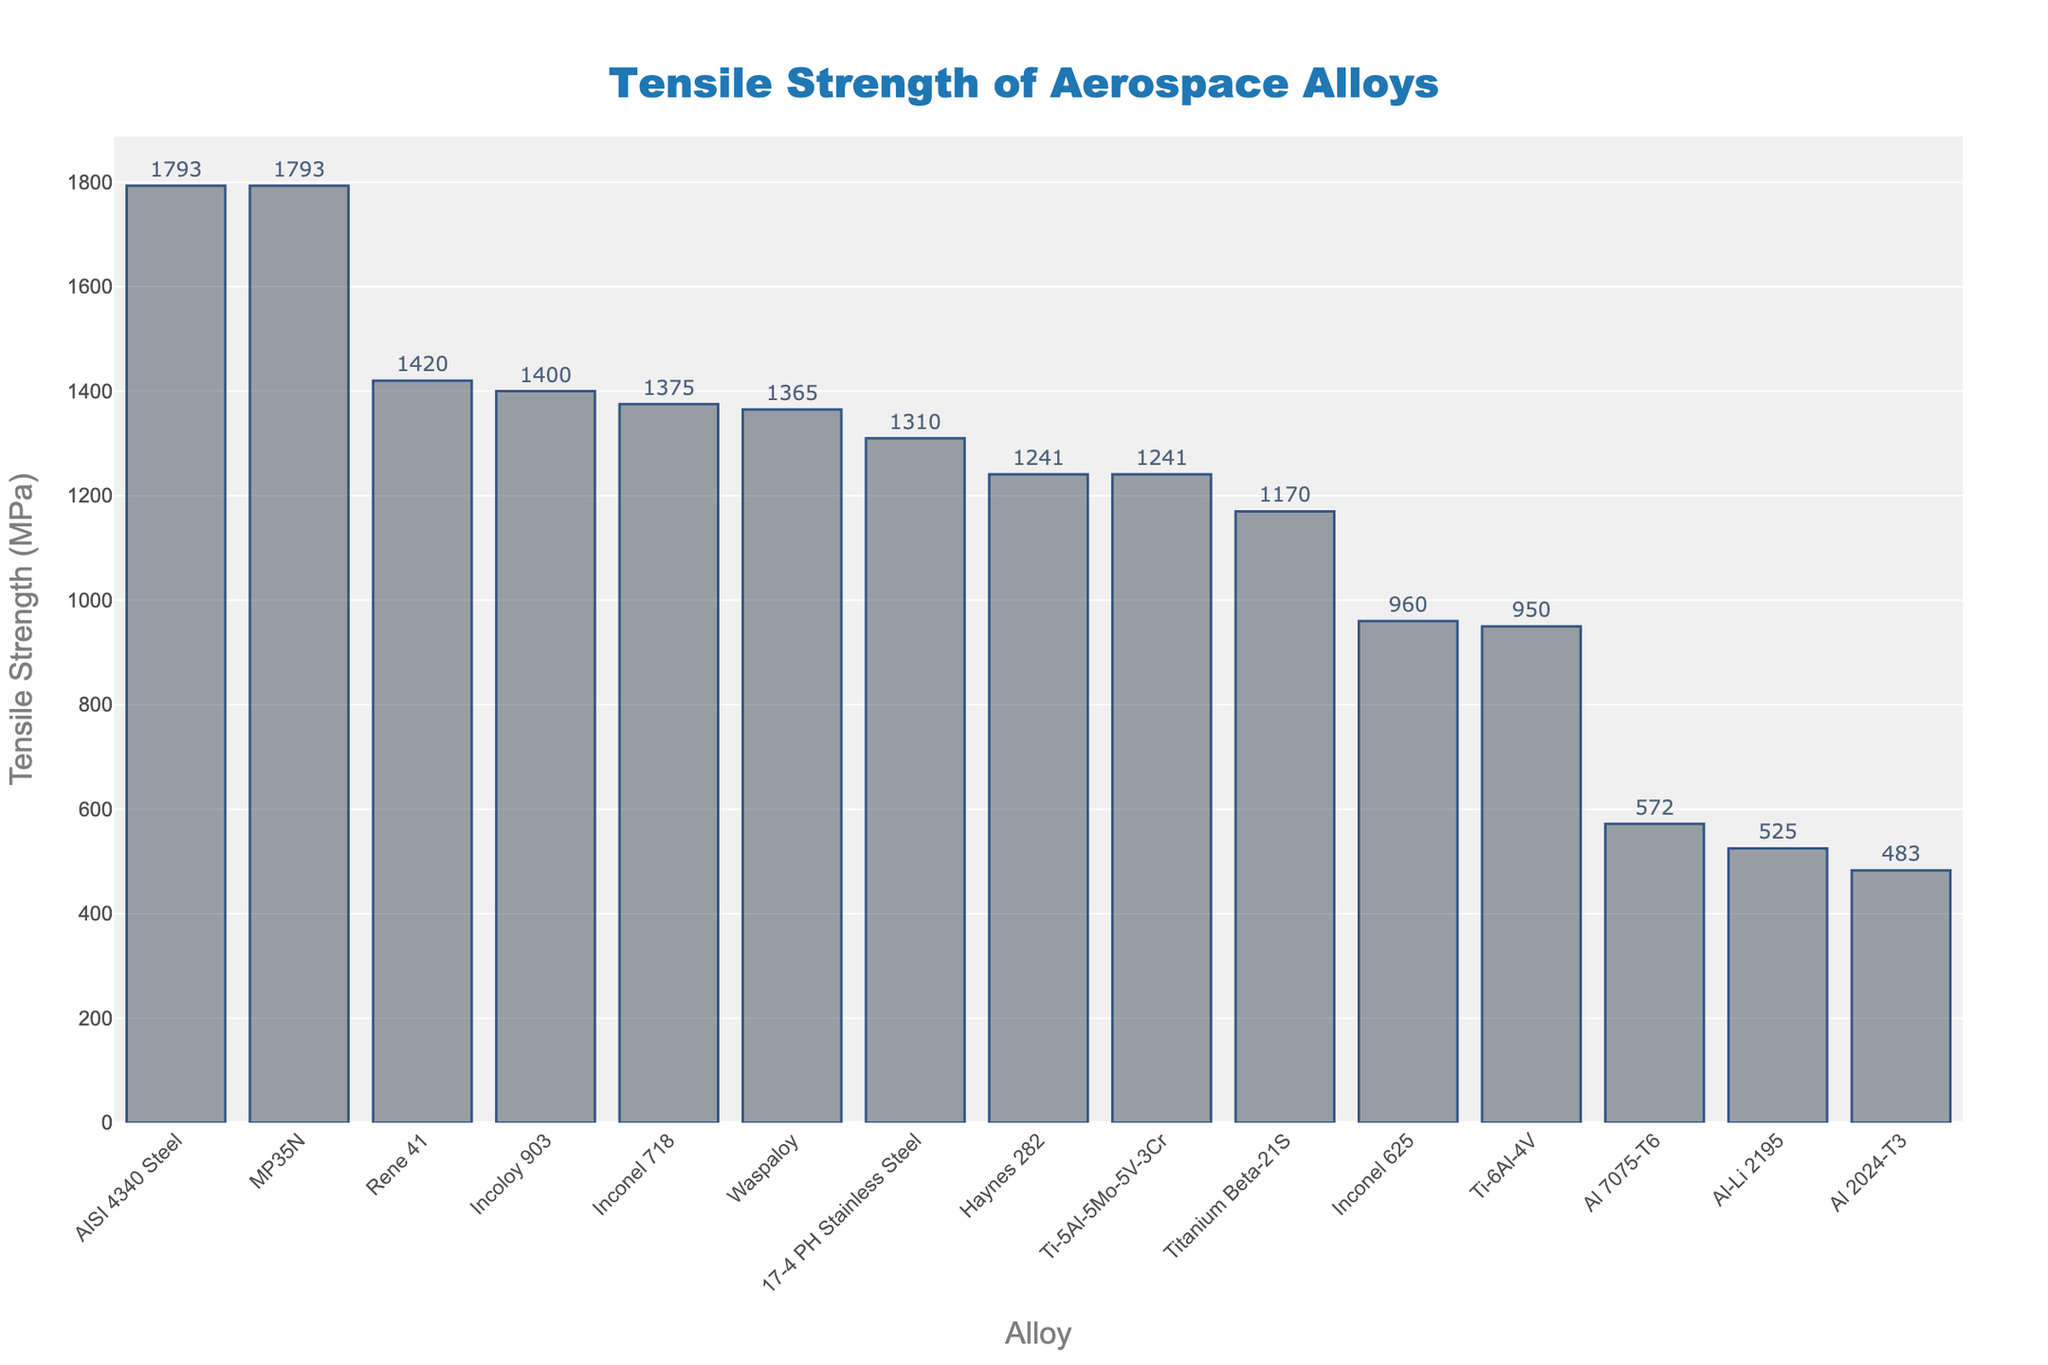Which alloy has the highest tensile strength? Look for the tallest bar in the chart, which represents the alloy with the highest tensile strength. The tallest bar belongs to AISI 4340 Steel with a tensile strength of 1793 MPa.
Answer: AISI 4340 Steel How much higher is the tensile strength of AISI 4340 Steel compared to Al 7075-T6? First, find the tensile strength of AISI 4340 Steel, which is 1793 MPa. Then find the tensile strength of Al 7075-T6, which is 572 MPa. Subtract the tensile strength of Al 7075-T6 from that of AISI 4340 Steel: 1793 - 572 = 1221 MPa.
Answer: 1221 MPa What is the average tensile strength of the three aluminum alloys shown in the chart? The aluminum alloys are Al 7075-T6 (572 MPa), Al-Li 2195 (525 MPa), and Al 2024-T3 (483 MPa). Sum these values: 572 + 525 + 483 = 1580 MPa. Divide by the number of alloys: 1580 / 3 ≈ 527 MPa.
Answer: 527 MPa Which alloy has a tensile strength closest to 1000 MPa? Examine the tensile strengths near 1000 MPa. The closest tensile strength to 1000 MPa is 960 MPa, which belongs to Inconel 625.
Answer: Inconel 625 Are there more alloys with tensile strength above or below 1200 MPa? Count the number of alloys with tensile strength above 1200 MPa (AISI 4340 Steel, Incoloy 903, Rene 41, Inconel 718, Waspaloy, MP35N, Haynes 282, and Ti-5Al-5Mo-5V-3Cr), which totals to 8. Count the number of alloys below 1200 MPa (Ti-6Al-4V, Titanium Beta-21S, 17-4 PH Stainless Steel, Inconel 625, Al 7075-T6, Al-Li 2195, and Al 2024-T3), which totals to 7. Thus, there are more alloys above 1200 MPa.
Answer: Above 1200 MPa What is the sum of the tensile strengths of the two lowest-strength alloys? Identify the two alloys with the lowest tensile strength: Al 2024-T3 (483 MPa) and Al-Li 2195 (525 MPa). Sum these values: 483 + 525 = 1008 MPa.
Answer: 1008 MPa Which alloy is represented by the second tallest bar in the figure? Identify the second tallest bar in the chart. The tallest bar is AISI 4340 Steel, and the second tallest bar represents MP35N, both with a tensile strength of 1793 MPa.
Answer: MP35N What is the difference in tensile strength between the two titanium alloys shown in the chart? Identify the tensile strengths of the two titanium alloys: Ti-6Al-4V (950 MPa) and Titanium Beta-21S (1170 MPa). Subtract the tensile strength of Ti-6Al-4V from that of Titanium Beta-21S: 1170 - 950 = 220 MPa.
Answer: 220 MPa Rank the top three alloys in terms of tensile strength. Identify the three tallest bars: AISI 4340 Steel (1793 MPa), MP35N (1793 MPa), and Rene 41 (1420 MPa). List them in descending order of tensile strength: AISI 4340 Steel, MP35N, Rene 41.
Answer: AISI 4340 Steel, MP35N, Rene 41 